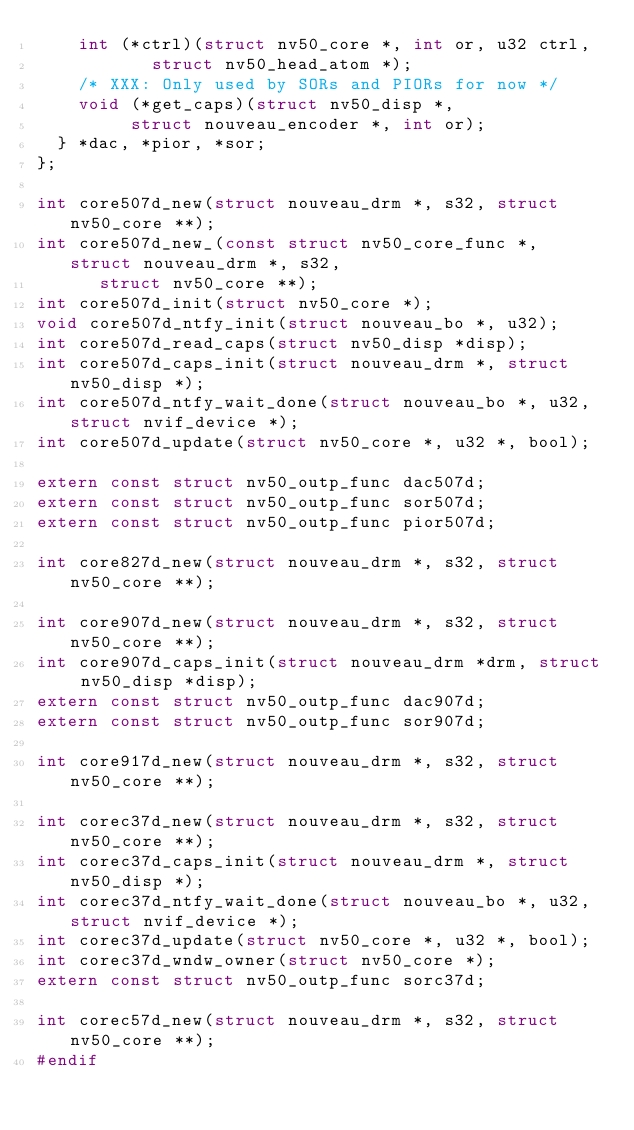<code> <loc_0><loc_0><loc_500><loc_500><_C_>		int (*ctrl)(struct nv50_core *, int or, u32 ctrl,
			     struct nv50_head_atom *);
		/* XXX: Only used by SORs and PIORs for now */
		void (*get_caps)(struct nv50_disp *,
				 struct nouveau_encoder *, int or);
	} *dac, *pior, *sor;
};

int core507d_new(struct nouveau_drm *, s32, struct nv50_core **);
int core507d_new_(const struct nv50_core_func *, struct nouveau_drm *, s32,
		  struct nv50_core **);
int core507d_init(struct nv50_core *);
void core507d_ntfy_init(struct nouveau_bo *, u32);
int core507d_read_caps(struct nv50_disp *disp);
int core507d_caps_init(struct nouveau_drm *, struct nv50_disp *);
int core507d_ntfy_wait_done(struct nouveau_bo *, u32, struct nvif_device *);
int core507d_update(struct nv50_core *, u32 *, bool);

extern const struct nv50_outp_func dac507d;
extern const struct nv50_outp_func sor507d;
extern const struct nv50_outp_func pior507d;

int core827d_new(struct nouveau_drm *, s32, struct nv50_core **);

int core907d_new(struct nouveau_drm *, s32, struct nv50_core **);
int core907d_caps_init(struct nouveau_drm *drm, struct nv50_disp *disp);
extern const struct nv50_outp_func dac907d;
extern const struct nv50_outp_func sor907d;

int core917d_new(struct nouveau_drm *, s32, struct nv50_core **);

int corec37d_new(struct nouveau_drm *, s32, struct nv50_core **);
int corec37d_caps_init(struct nouveau_drm *, struct nv50_disp *);
int corec37d_ntfy_wait_done(struct nouveau_bo *, u32, struct nvif_device *);
int corec37d_update(struct nv50_core *, u32 *, bool);
int corec37d_wndw_owner(struct nv50_core *);
extern const struct nv50_outp_func sorc37d;

int corec57d_new(struct nouveau_drm *, s32, struct nv50_core **);
#endif
</code> 